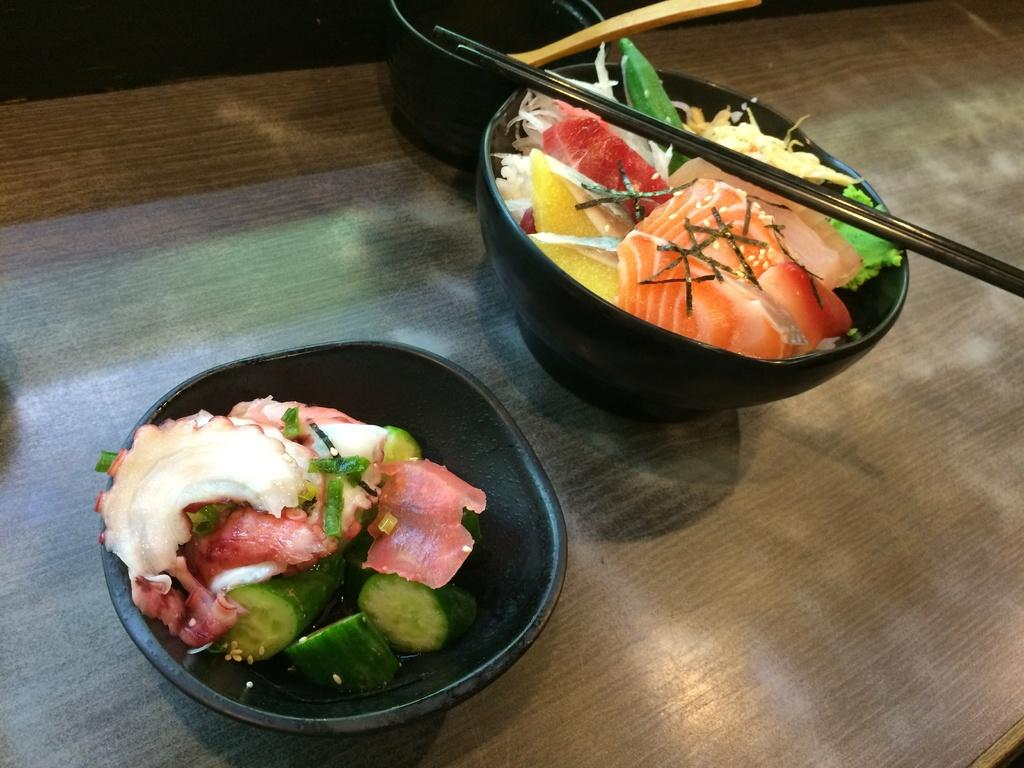What type of furniture is in the image? There is a table in the image. What is placed on the table? There are bowls on the table. What utensils are present on the table? Chopsticks and a spoon are present on the table. What can be inferred about the purpose of the table from the items on it? The table is likely used for serving or eating food, as there are bowls, chopsticks, and a spoon present. What type of food items can be seen on the table? Food items are visible on the table. Where is the nest located in the image? There is no nest present in the image. What appliance can be seen on the table in the image? There is no appliance visible on the table in the image. 